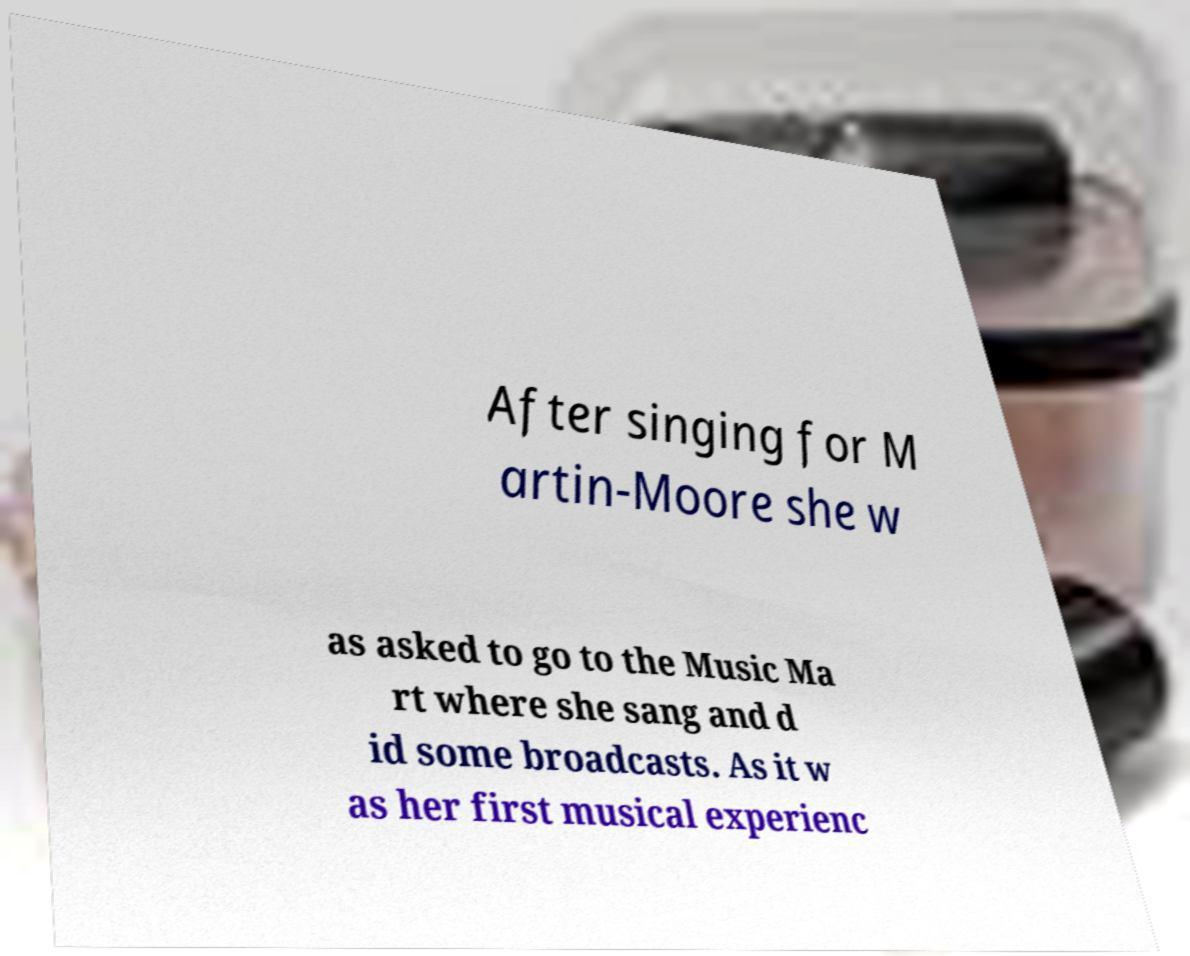There's text embedded in this image that I need extracted. Can you transcribe it verbatim? After singing for M artin-Moore she w as asked to go to the Music Ma rt where she sang and d id some broadcasts. As it w as her first musical experienc 